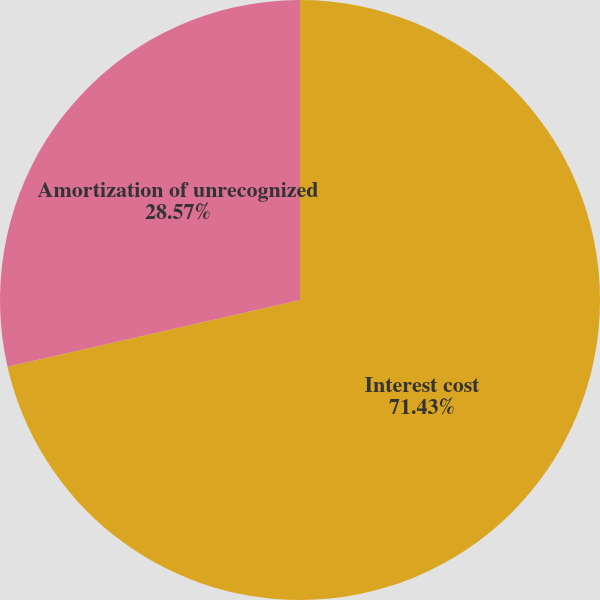Convert chart. <chart><loc_0><loc_0><loc_500><loc_500><pie_chart><fcel>Interest cost<fcel>Amortization of unrecognized<nl><fcel>71.43%<fcel>28.57%<nl></chart> 